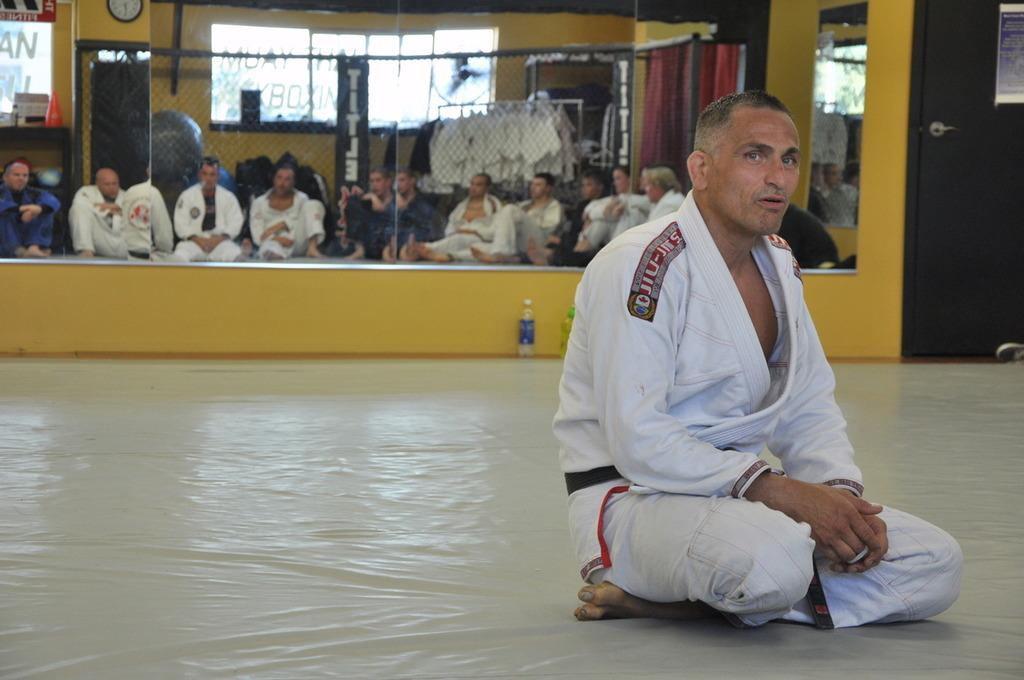<image>
Render a clear and concise summary of the photo. Man wearing a karate outfit with the word JIU on it. 